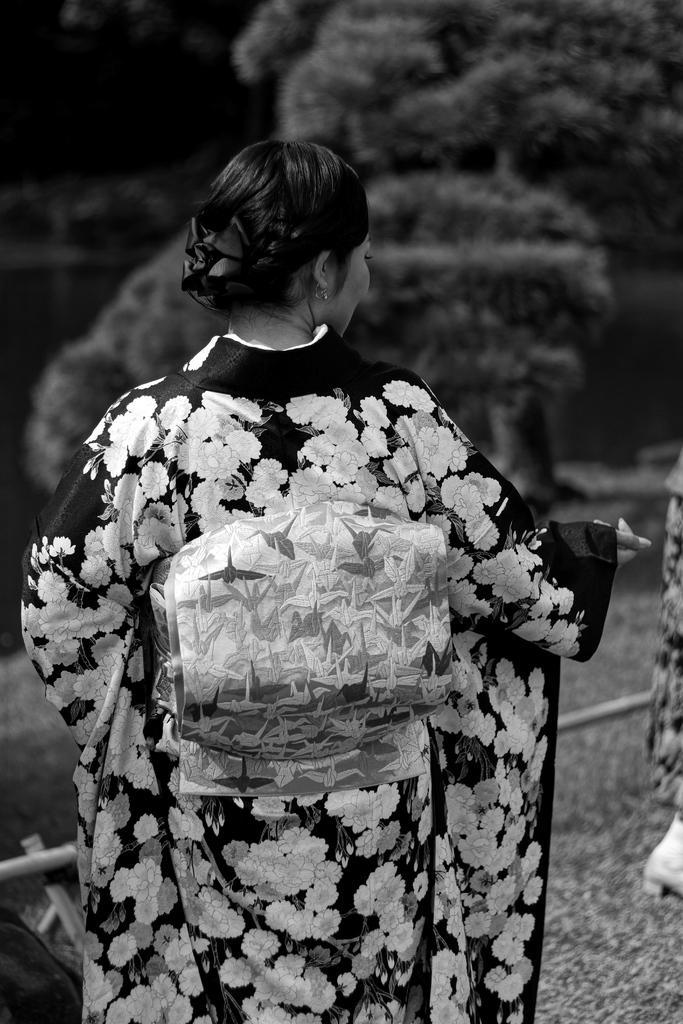Could you give a brief overview of what you see in this image? In this picture we can see a woman is standing in the front, in the background there are trees, it is a black and white image. 